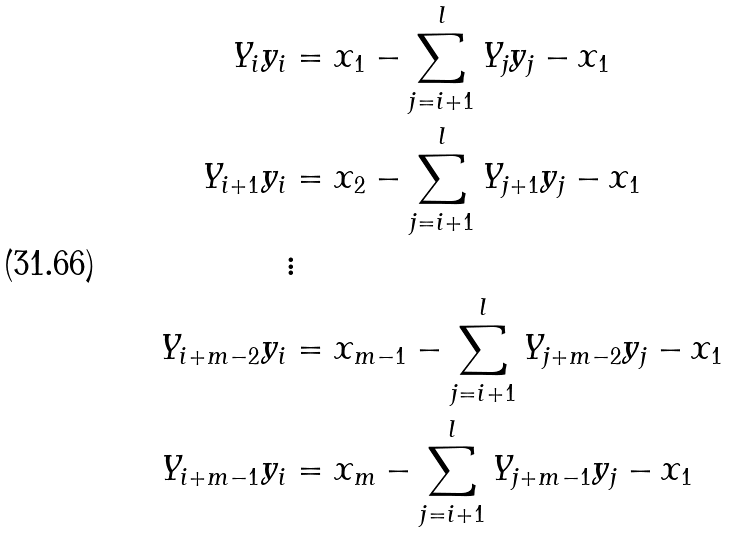Convert formula to latex. <formula><loc_0><loc_0><loc_500><loc_500>Y _ { i } y _ { i } & = x _ { 1 } - \sum _ { j = i + 1 } ^ { l } Y _ { j } y _ { j } - x _ { 1 } \\ Y _ { i + 1 } y _ { i } & = x _ { 2 } - \sum _ { j = i + 1 } ^ { l } Y _ { j + 1 } y _ { j } - x _ { 1 } \\ & \vdots \\ Y _ { i + m - 2 } y _ { i } & = x _ { m - 1 } - \sum _ { j = i + 1 } ^ { l } Y _ { j + m - 2 } y _ { j } - x _ { 1 } \\ Y _ { i + m - 1 } y _ { i } & = x _ { m } - \sum _ { j = i + 1 } ^ { l } Y _ { j + m - 1 } y _ { j } - x _ { 1 }</formula> 